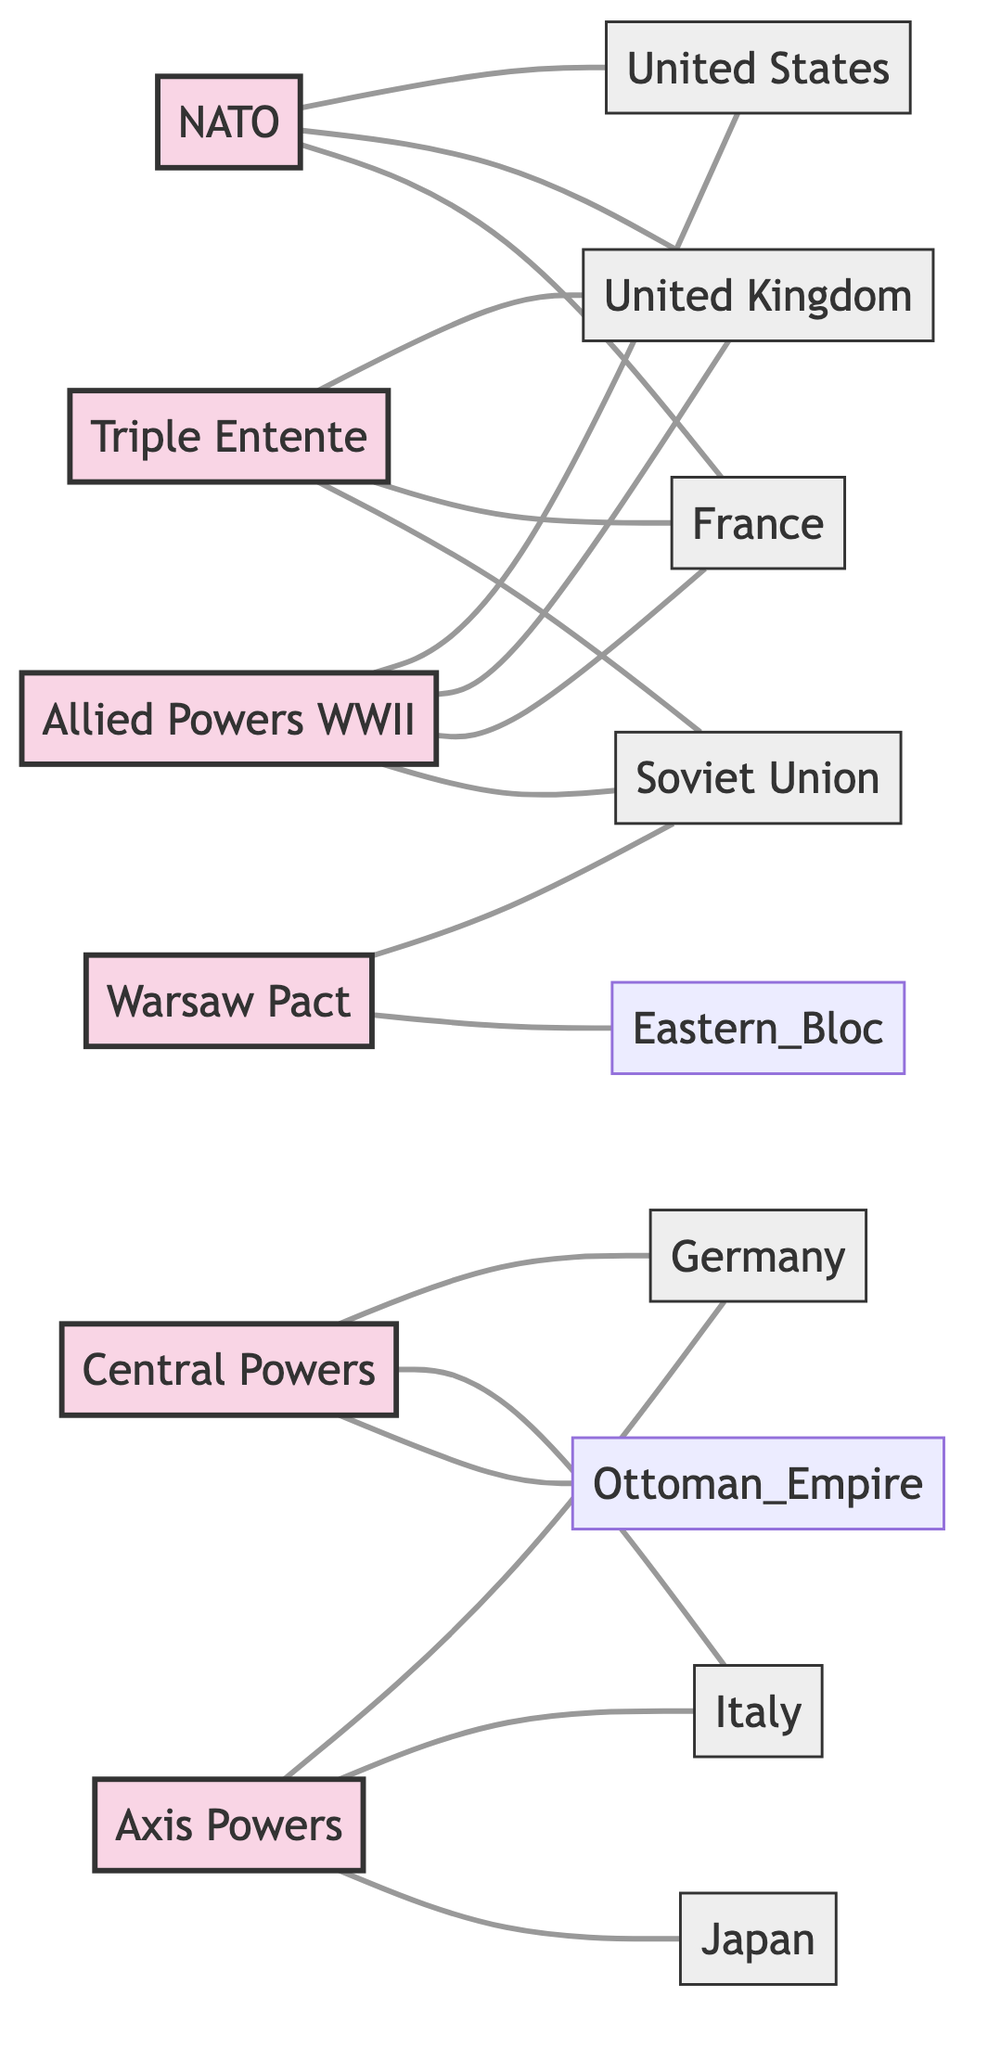What is the total number of alliances depicted in the diagram? Counting the nodes categorized as alliances, we have Triple Entente, Central Powers, NATO, Warsaw Pact, Allied Powers (WWII), and Axis Powers, resulting in a total of 6.
Answer: 6 Which country is connected to the Triple Entente alliance? The nodes connected to the Triple Entente are the United Kingdom, France, and the Soviet Union, indicating those countries were part of this alliance.
Answer: United Kingdom, France, Soviet Union How many countries are linked to NATO? Upon reviewing the edges connecting to NATO, we observe connections to the United States, United Kingdom, and France, totaling 3.
Answer: 3 What two alliances are connected to the Soviet Union? The Soviet Union connects to the Triple Entente and Warsaw Pact, showing its involvement in both alliances throughout different historical contexts.
Answer: Triple Entente, Warsaw Pact Which country belongs to the Axis Powers alliance? Looking at the nodes labeled under the Axis Powers, we identify Germany, Italy, and Japan as members of this alliance.
Answer: Germany, Italy, Japan How many countries are associated with the Allied Powers during World War II? The Allied Powers during World War II are linked to four countries: the United States, United Kingdom, France, and the Soviet Union, leading to a total of 4.
Answer: 4 Which alliance has Germany as a member? Analyzing the connections, Germany is linked to both the Central Powers and the Axis Powers, thus indicating its role in both.
Answer: Central Powers, Axis Powers What is the relationship between NATO and member countries? The connections from NATO extend to the United States, United Kingdom, and France, illustrating its foundations in these nations.
Answer: United States, United Kingdom, France Which alliances are directly opposed to each other in the diagram? The diagram shows that NATO and the Warsaw Pact represent opposing alliances, the former being a Western alliance and the latter representing the Eastern Bloc.
Answer: NATO, Warsaw Pact 